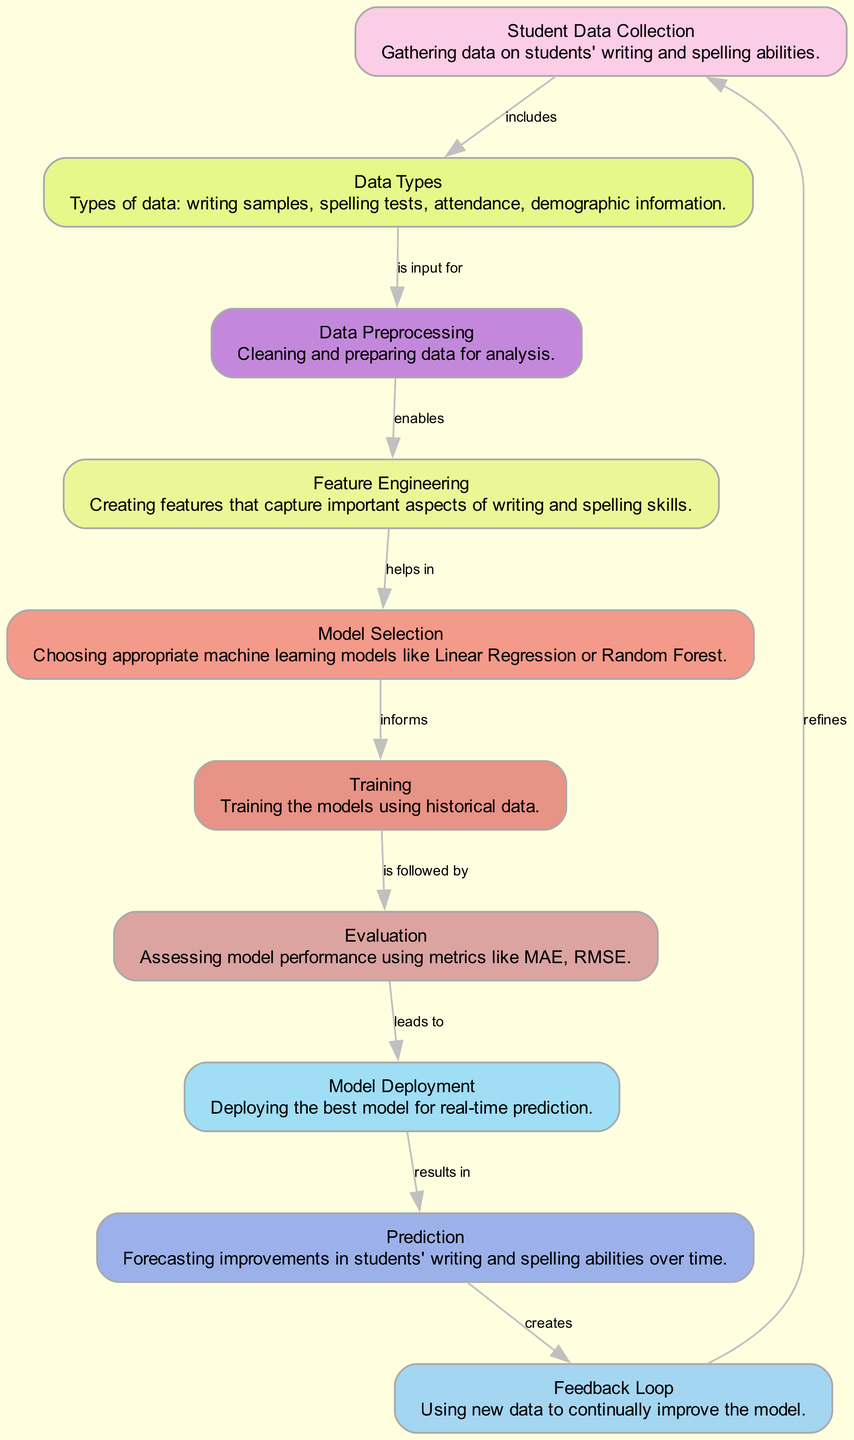What is the first step in the predictive analysis process? The first step involves gathering data on students' writing and spelling abilities, represented by the node "Student Data Collection."
Answer: Student Data Collection How many nodes are in the diagram? By counting the listed nodes, we find there are ten nodes representing various components of the machine learning process for predicting student progress.
Answer: 10 What follows after Data Preprocessing? After Data Preprocessing, the next step is Feature Engineering, as indicated by the directed edge in the diagram, which shows this connection.
Answer: Feature Engineering Which data types are included in the analysis? The node "Data Types" specifies the types of data collected, including writing samples, spelling tests, attendance, and demographic information.
Answer: Writing samples, spelling tests, attendance, demographic information What leads to Model Deployment? The Evaluation step assesses model performance and leads to Model Deployment, demonstrating a sequence in the predictive analysis process.
Answer: Evaluation What is the function of the Feedback Loop? The Feedback Loop utilizes new data to continually refine and improve the model, making it an essential component for enhancing the prediction accuracy over time.
Answer: Refines Which machine learning models might be chosen during Model Selection? The options mentioned for selection of machine learning models include Linear Regression and Random Forest, both of which are commonly used for predictive tasks.
Answer: Linear Regression, Random Forest How does Feature Engineering help in the analysis? Feature Engineering helps in Model Selection by creating important features that influence the predictive capability of the chosen models, making it a critical step in preparation.
Answer: Helps in Model Selection What is the final outcome achieved from Prediction? The final outcome from the Prediction step is the forecasting of improvements in students' writing and spelling abilities over time, which is the ultimate goal of the predictive analysis process.
Answer: Forecasting improvements 